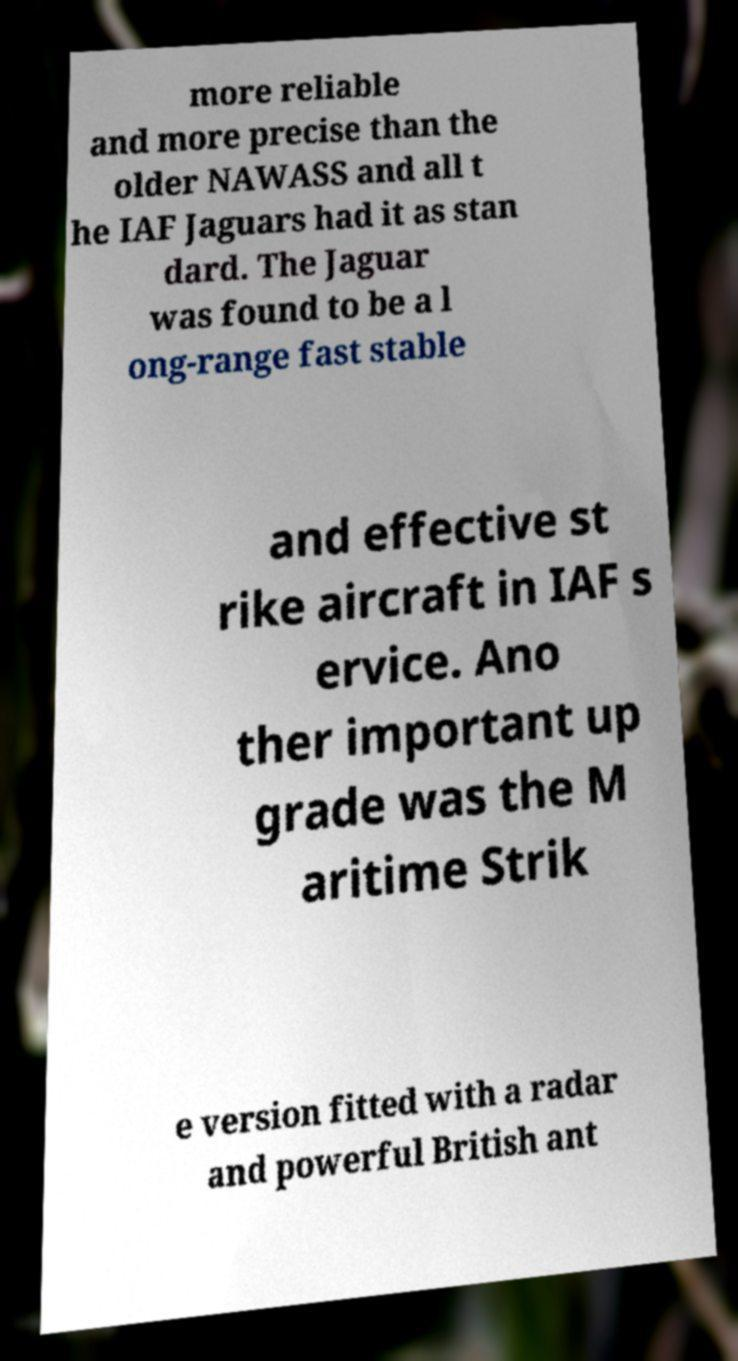Can you accurately transcribe the text from the provided image for me? more reliable and more precise than the older NAWASS and all t he IAF Jaguars had it as stan dard. The Jaguar was found to be a l ong-range fast stable and effective st rike aircraft in IAF s ervice. Ano ther important up grade was the M aritime Strik e version fitted with a radar and powerful British ant 